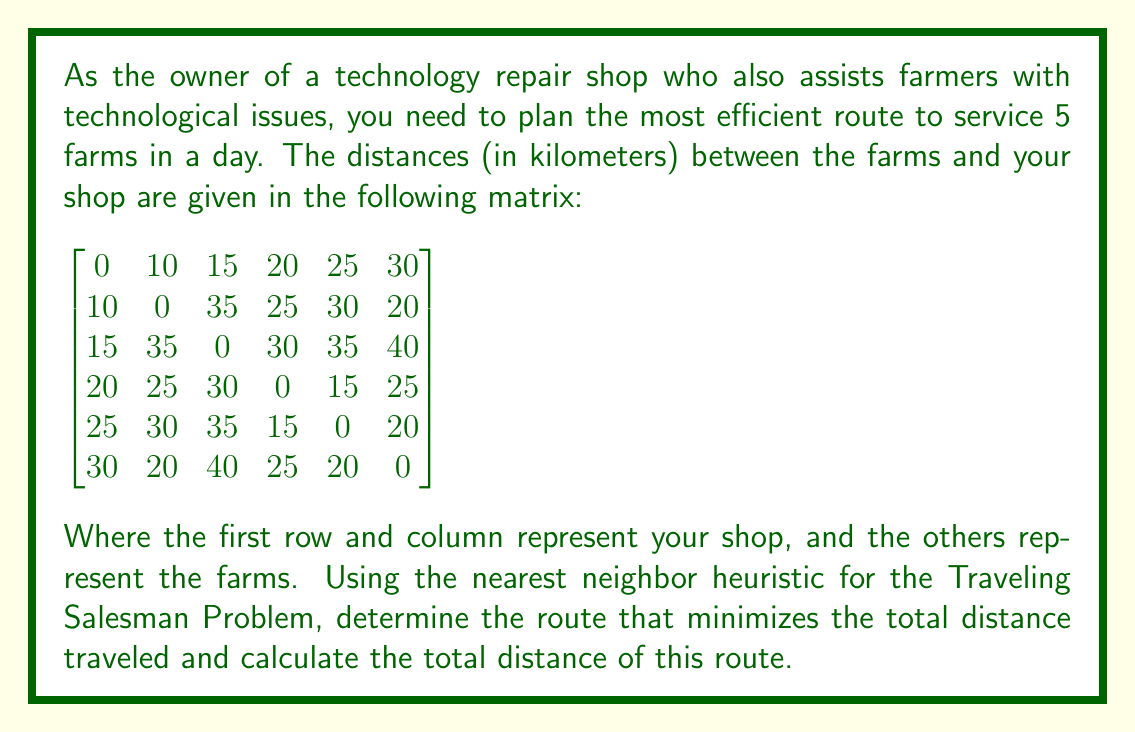Can you answer this question? To solve this problem using the nearest neighbor heuristic for the Traveling Salesman Problem, we'll follow these steps:

1. Start at the shop (vertex 0).
2. Find the nearest unvisited farm and move to it.
3. Repeat step 2 until all farms have been visited.
4. Return to the shop.

Let's go through the process:

1. Start at the shop (0).

2. Find the nearest farm:
   Farm 1: 10 km
   Farm 2: 15 km
   Farm 3: 20 km
   Farm 4: 25 km
   Farm 5: 30 km
   
   The nearest is Farm 1, so we move there. Distance: 10 km

3. From Farm 1, find the nearest unvisited farm:
   Farm 2: 35 km
   Farm 3: 25 km
   Farm 4: 30 km
   Farm 5: 20 km
   
   The nearest is Farm 5. Distance: 20 km

4. From Farm 5, find the nearest unvisited farm:
   Farm 2: 35 km
   Farm 3: 25 km
   Farm 4: 15 km
   
   The nearest is Farm 4. Distance: 15 km

5. From Farm 4, find the nearest unvisited farm:
   Farm 2: 25 km
   Farm 3: 30 km
   
   The nearest is Farm 2. Distance: 25 km

6. The only farm left is Farm 3. Distance from Farm 2 to Farm 3: 35 km

7. Return to the shop from Farm 3. Distance: 15 km

The route is: Shop → Farm 1 → Farm 5 → Farm 4 → Farm 2 → Farm 3 → Shop

To calculate the total distance:
$$ \text{Total Distance} = 10 + 20 + 15 + 25 + 35 + 15 = 120 \text{ km} $$
Answer: The most efficient route using the nearest neighbor heuristic is:
Shop → Farm 1 → Farm 5 → Farm 4 → Farm 2 → Farm 3 → Shop

Total distance: 120 km 